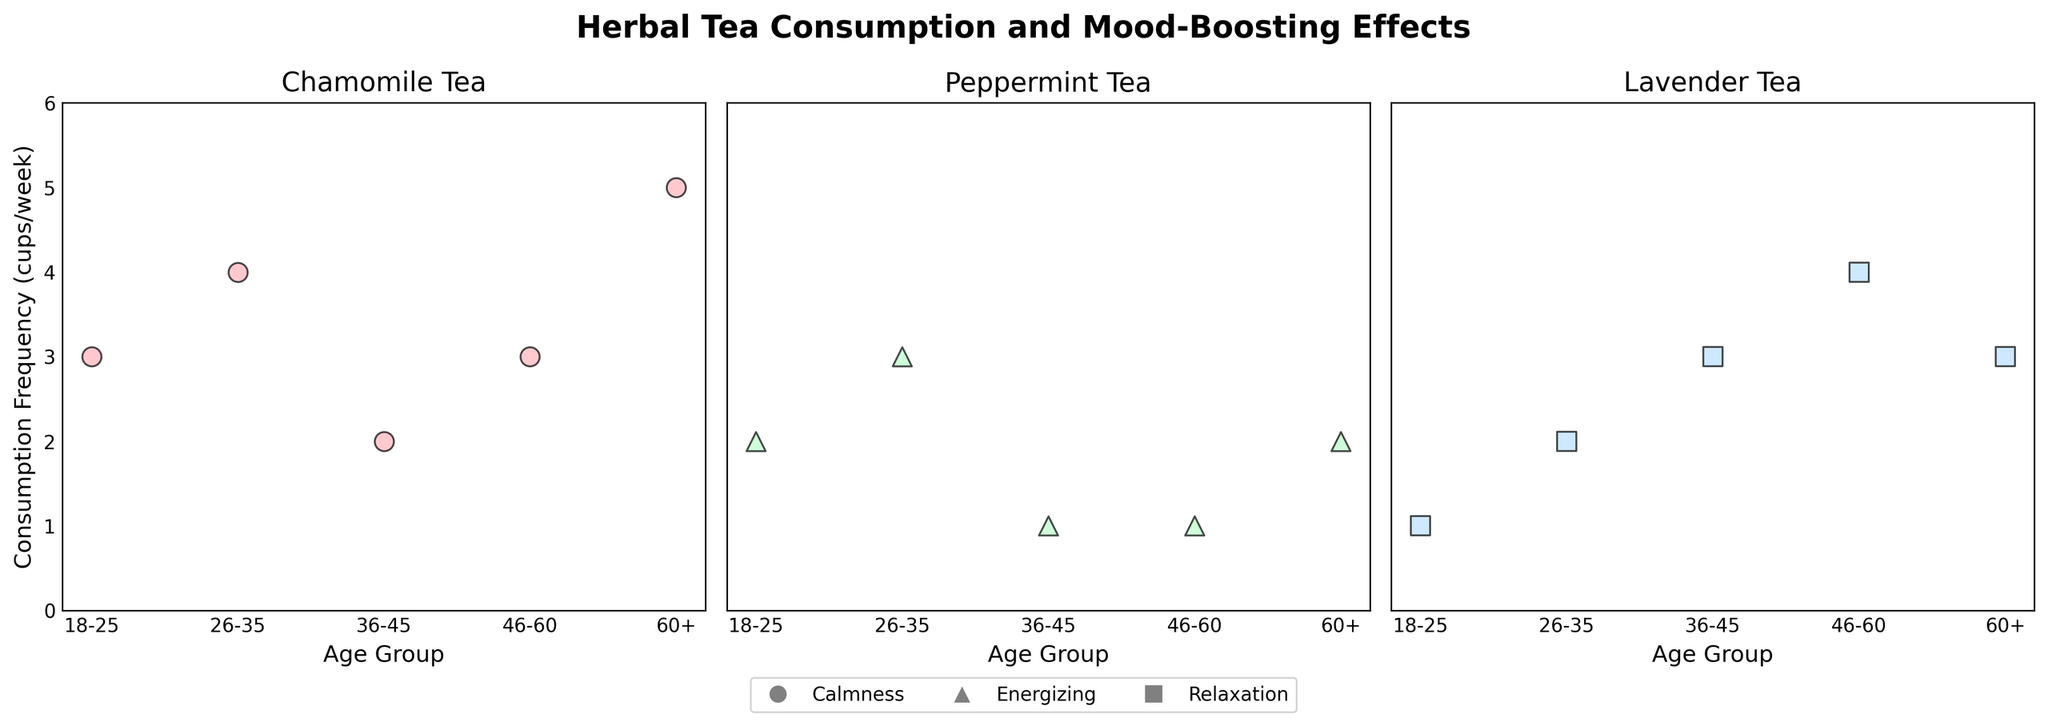What is the title of the figure? The title is located at the top of the plot and summarizes the content of the figure.
Answer: Herbal Tea Consumption and Mood-Boosting Effects How many different age groups are represented in the plot? There are five distinct markers along the x-axis representing different age groups.
Answer: Five (18-25, 26-35, 36-45, 46-60, 60+) What is the highest consumption frequency for Chamomile tea? By observing the Chamomile subplot, we can see that the highest y-value on this subplot is 5 cups/week.
Answer: 5 cups/week In which subplot is calmness associated with the highest consumption frequency? Calmness is represented by circle markers (o). The highest consumption frequency for 'Calmness' markers appears in the subplot for Chamomile tea.
Answer: Chamomile tea Which age group consumes Peppermint tea the least? By comparing all the points in the Peppermint tea subplot, the age group with the minimum y-value (1 cup/week) is 46-60 and 36-45.
Answer: 46-60 and 36-45 What is the average consumption frequency of Lavender tea for age groups 26-35 and 46-60? First, find the frequencies for these groups in the Lavender subplot: 2 (26-35) and 4 (46-60), then calculate the average (2 + 4) / 2 = 3 cups/week.
Answer: 3 cups/week Which mood-boosting effect has the highest consumption frequency across all age groups for Lavender tea? Look for the highest marker in the Lavender subplot. The square markers (Relaxation) reach a consumption frequency of 4 cups/week in the 46-60 age group.
Answer: Relaxation In which subplot do we see the least variation in consumption frequency across age groups? The Peppermint subplot has fewer and closer-spread points compared to Chamomile and Lavender, indicating the least variation.
Answer: Peppermint Is there an age group that consumes all three types of herbal teas? Observe if a marker appears in all three subplots for any age group. The 60+ age group is represented in all three subplots (Chamomile, Peppermint, and Lavender).
Answer: 60+ Which age group shows a maximum consumption frequency for Energizing mood? Energizing mood is represented by a triangle marker (^). The highest triangle marker appears in the 26-35 age group for Peppermint tea.
Answer: 26-35 